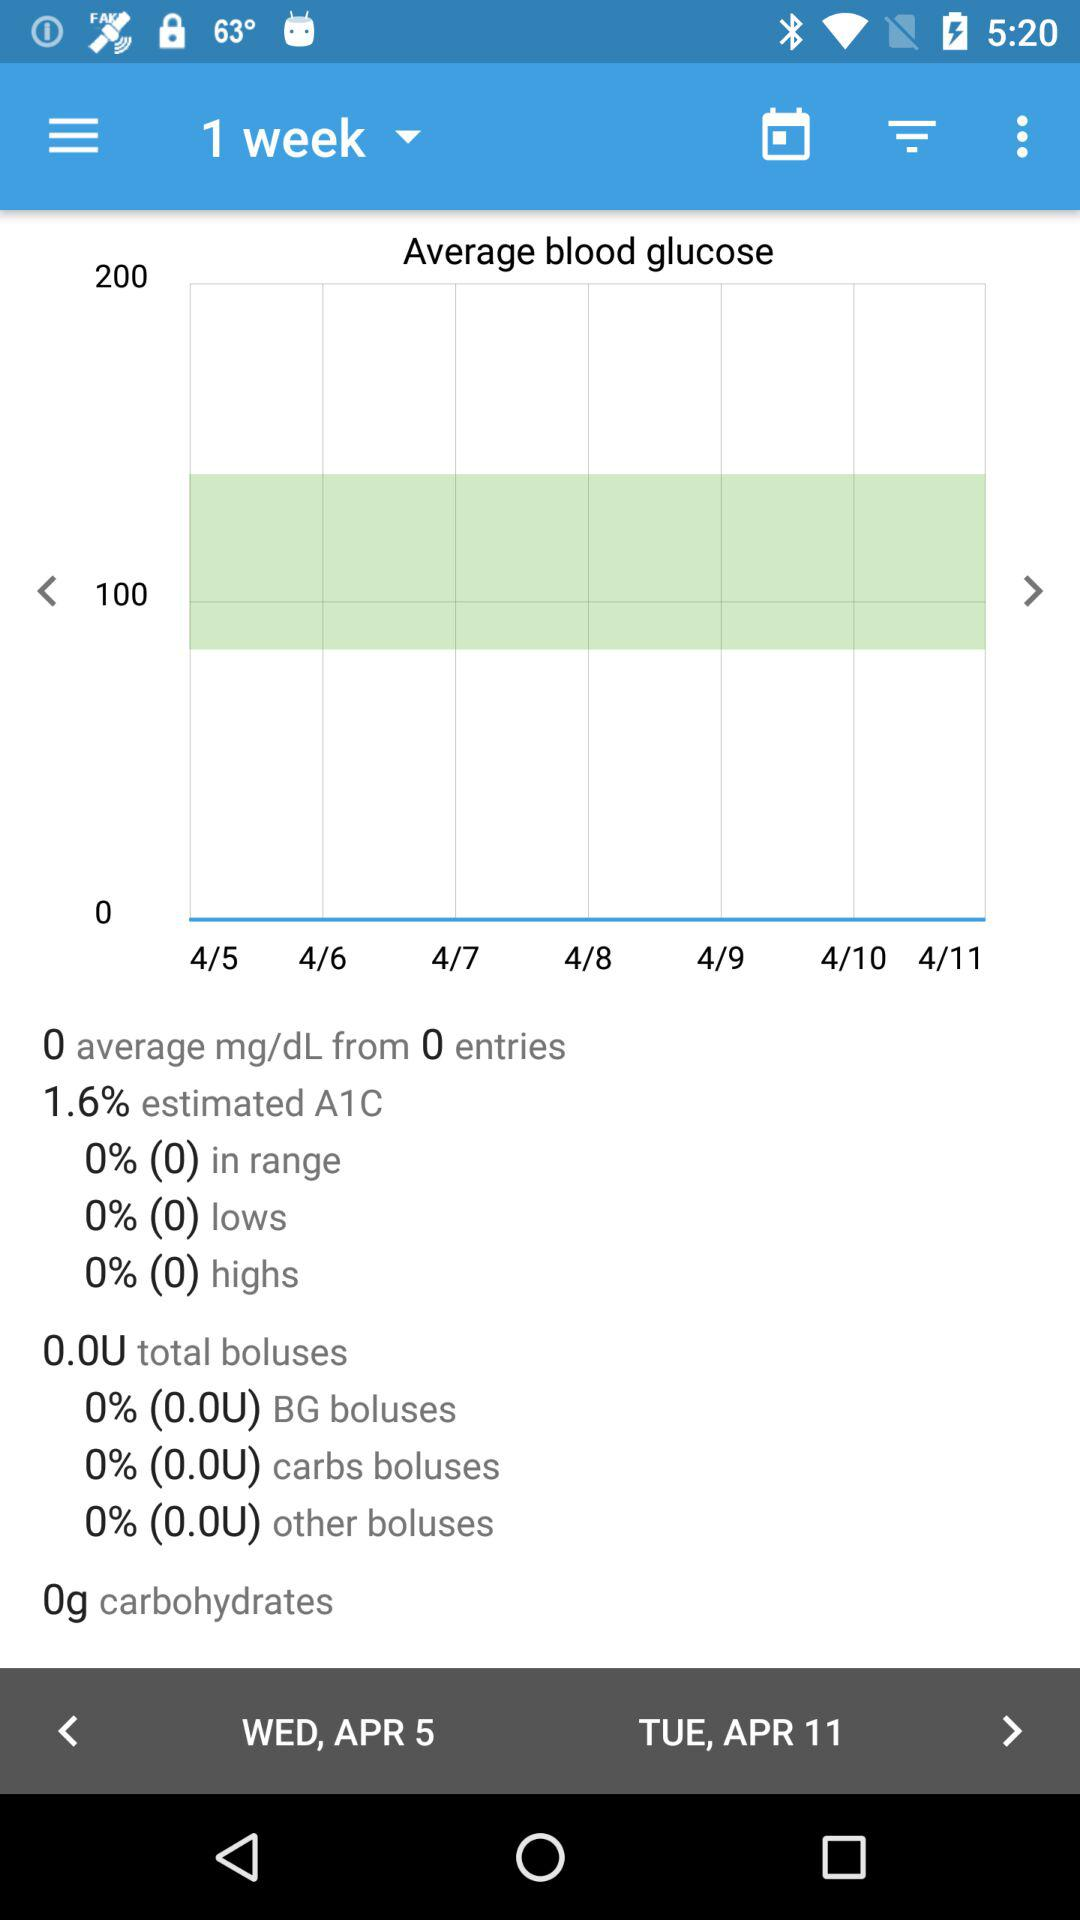What is the amount of carbohydrates? The amount of carbohydrates is 0 grams. 